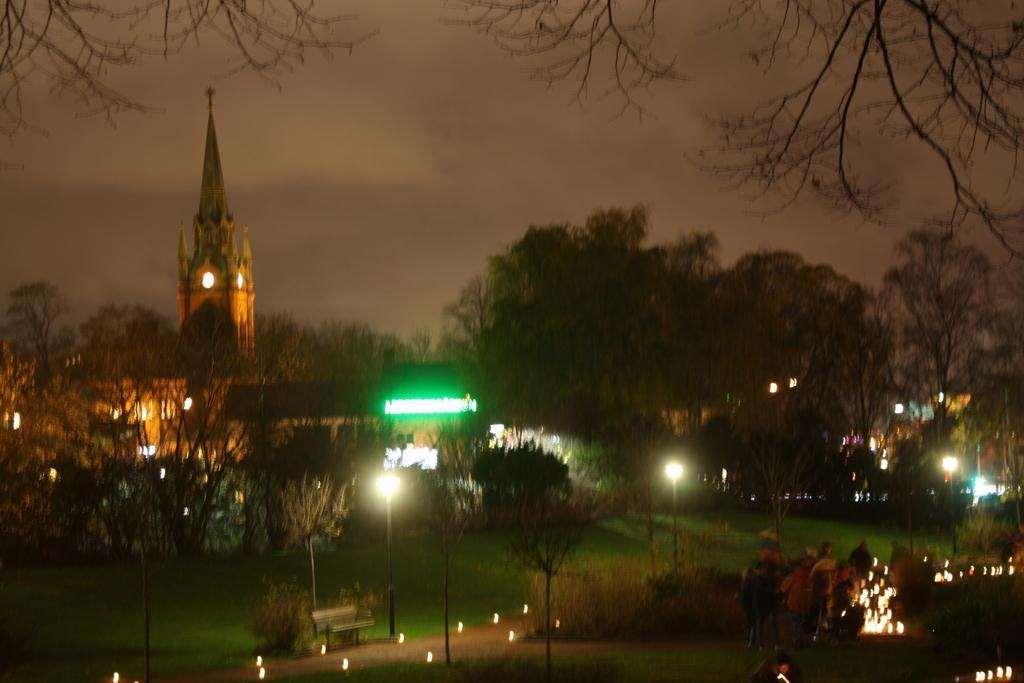What type of natural elements can be seen in the image? There are trees in the image. What artificial elements can be seen in the image? There are lights and a bench visible in the image. Are there any people present in the image? Yes, there are people in the image. What can be seen in the background of the image? There is a building visible in the background. How would you describe the weather in the image? The sky is cloudy in the image. How many eggs are hanging from the trees in the image? There are no eggs present in the image; it features trees, lights, a bench, people, a building, and a cloudy sky. What type of cent is visible in the image? There is no cent present in the image. 